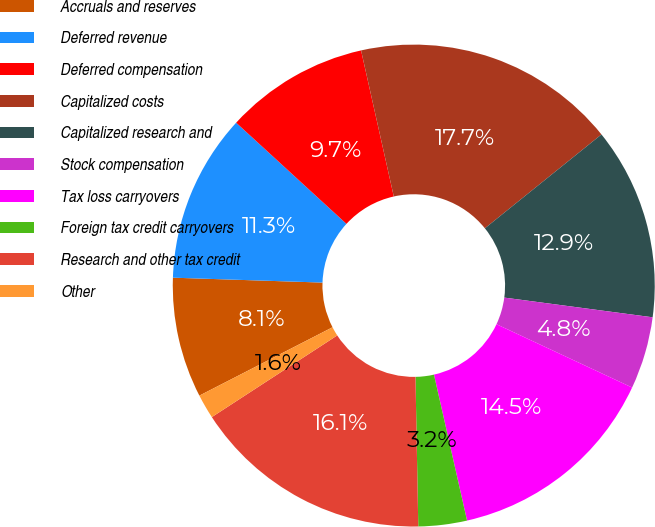Convert chart to OTSL. <chart><loc_0><loc_0><loc_500><loc_500><pie_chart><fcel>Accruals and reserves<fcel>Deferred revenue<fcel>Deferred compensation<fcel>Capitalized costs<fcel>Capitalized research and<fcel>Stock compensation<fcel>Tax loss carryovers<fcel>Foreign tax credit carryovers<fcel>Research and other tax credit<fcel>Other<nl><fcel>8.07%<fcel>11.29%<fcel>9.68%<fcel>17.72%<fcel>12.89%<fcel>4.85%<fcel>14.5%<fcel>3.25%<fcel>16.11%<fcel>1.64%<nl></chart> 